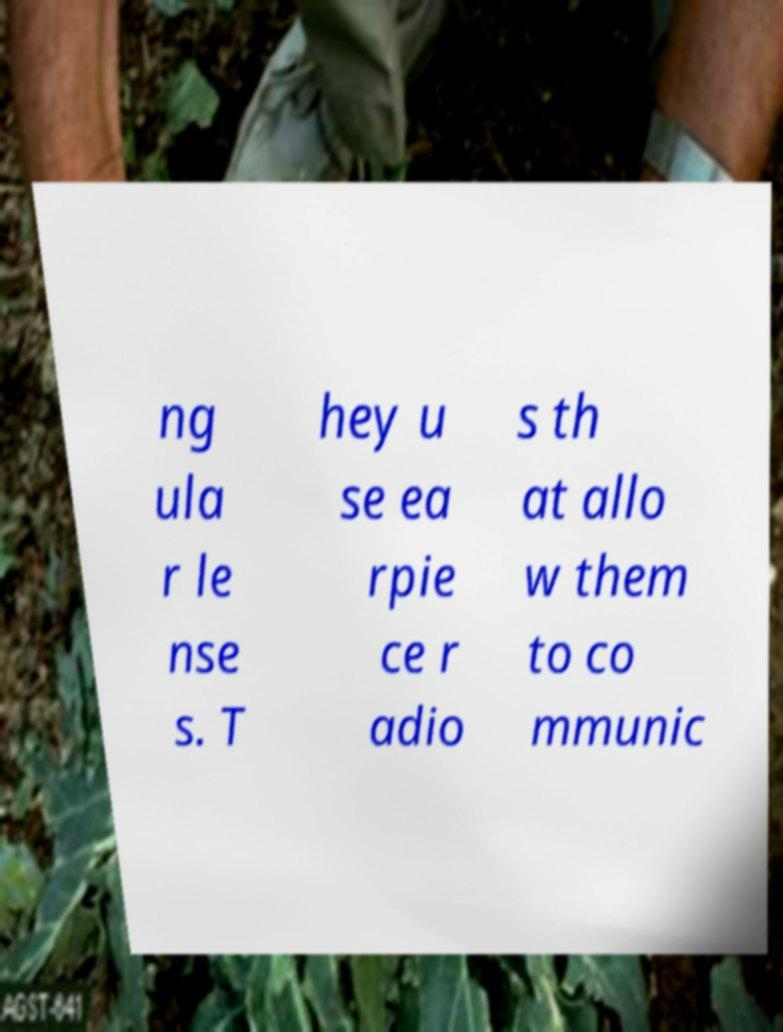Can you accurately transcribe the text from the provided image for me? ng ula r le nse s. T hey u se ea rpie ce r adio s th at allo w them to co mmunic 